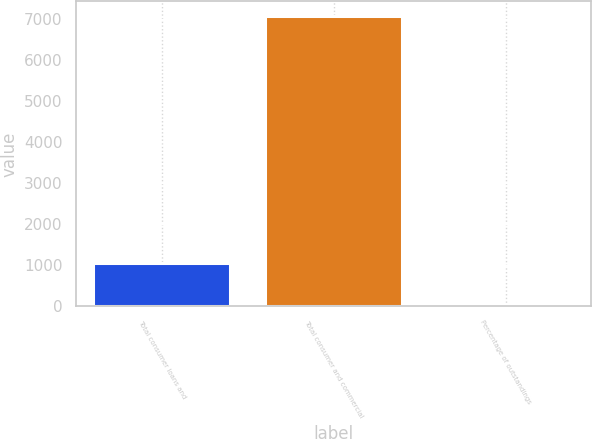Convert chart. <chart><loc_0><loc_0><loc_500><loc_500><bar_chart><fcel>Total consumer loans and<fcel>Total consumer and commercial<fcel>Percentage of outstandings<nl><fcel>1051<fcel>7085<fcel>0.77<nl></chart> 